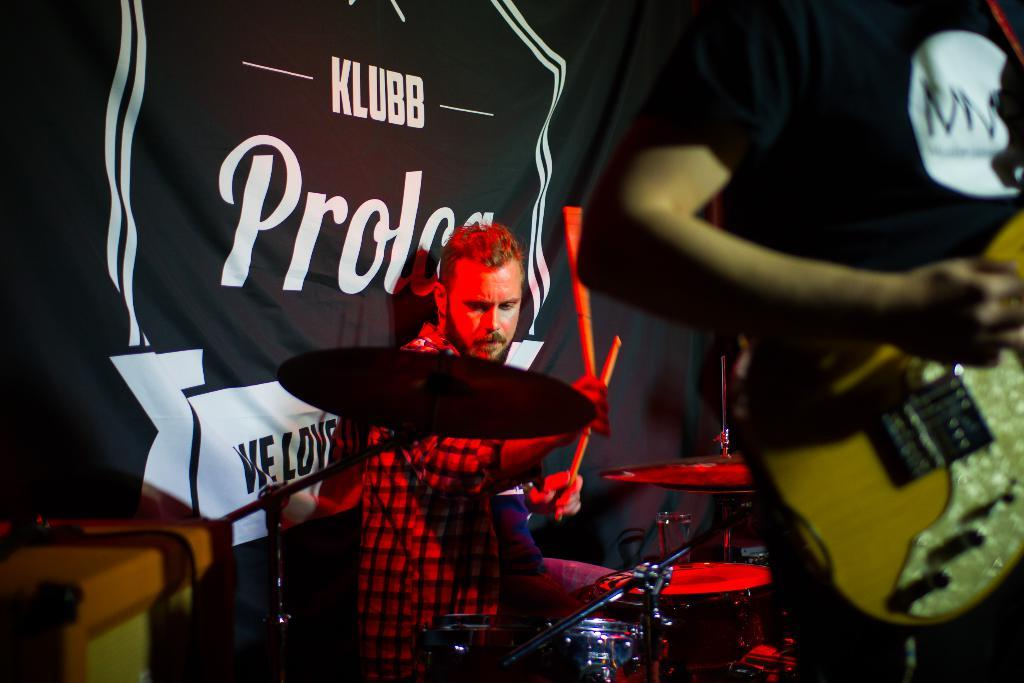How many people are on the stage in the image? There are two men on the stage in the image. What are the men doing on the stage? One of the men is holding a guitar, and the other man is playing drums. What can be seen behind the men on the stage? There is a black cloth behind them. What type of action can be seen in the sky in the image? There is no sky visible in the image, as it is focused on the stage with the two men. 